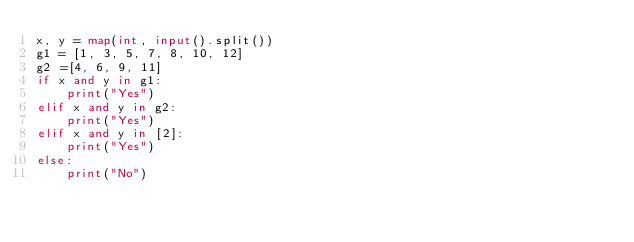Convert code to text. <code><loc_0><loc_0><loc_500><loc_500><_Python_>x, y = map(int, input().split())
g1 = [1, 3, 5, 7, 8, 10, 12]
g2 =[4, 6, 9, 11]
if x and y in g1:
    print("Yes")
elif x and y in g2:
    print("Yes")
elif x and y in [2]:
    print("Yes")
else:
    print("No")</code> 